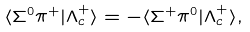<formula> <loc_0><loc_0><loc_500><loc_500>\langle \Sigma ^ { 0 } \pi ^ { + } | \Lambda ^ { + } _ { c } \rangle = - \langle \Sigma ^ { + } \pi ^ { 0 } | \Lambda ^ { + } _ { c } \rangle ,</formula> 